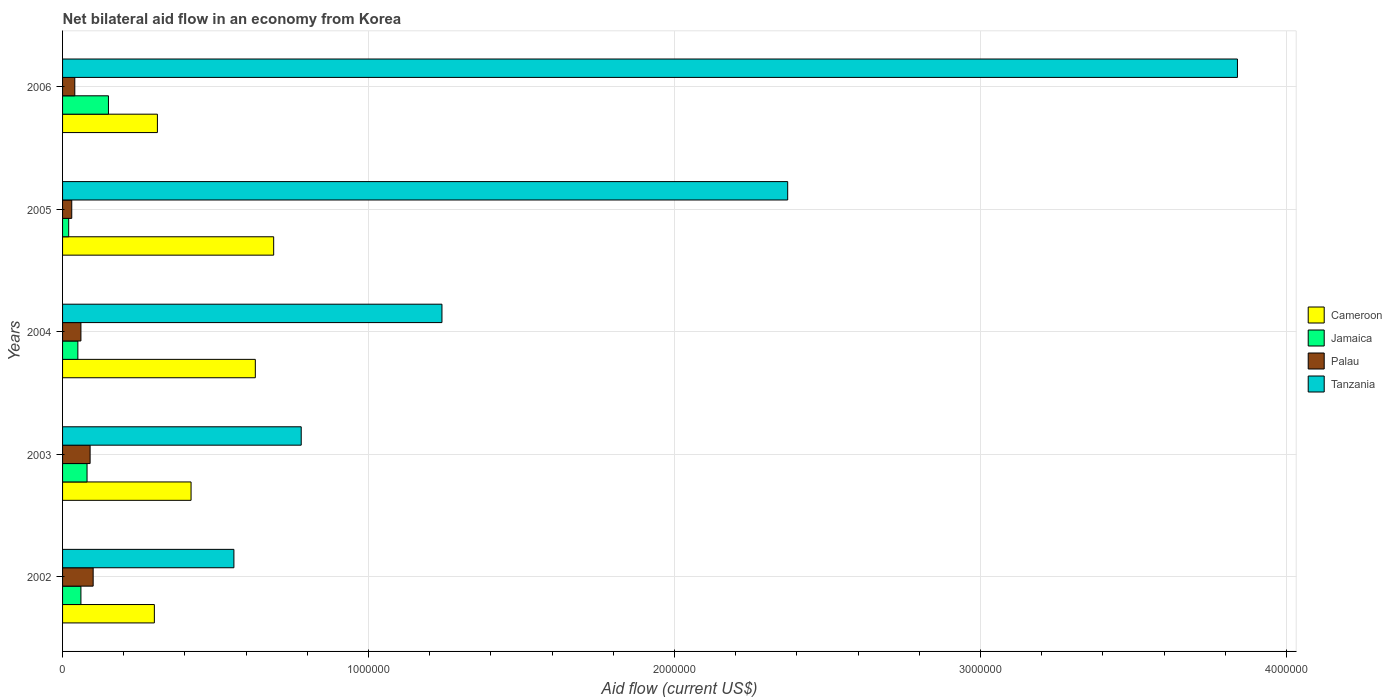Are the number of bars per tick equal to the number of legend labels?
Your answer should be compact. Yes. How many bars are there on the 4th tick from the top?
Your response must be concise. 4. How many bars are there on the 1st tick from the bottom?
Give a very brief answer. 4. What is the label of the 4th group of bars from the top?
Your answer should be compact. 2003. In how many cases, is the number of bars for a given year not equal to the number of legend labels?
Give a very brief answer. 0. Across all years, what is the maximum net bilateral aid flow in Jamaica?
Offer a very short reply. 1.50e+05. What is the total net bilateral aid flow in Cameroon in the graph?
Your answer should be compact. 2.35e+06. What is the difference between the net bilateral aid flow in Cameroon in 2006 and the net bilateral aid flow in Tanzania in 2005?
Keep it short and to the point. -2.06e+06. What is the average net bilateral aid flow in Palau per year?
Your answer should be very brief. 6.40e+04. In the year 2006, what is the difference between the net bilateral aid flow in Tanzania and net bilateral aid flow in Cameroon?
Offer a very short reply. 3.53e+06. What is the ratio of the net bilateral aid flow in Cameroon in 2004 to that in 2005?
Ensure brevity in your answer.  0.91. Is the net bilateral aid flow in Jamaica in 2002 less than that in 2003?
Your answer should be very brief. Yes. Is the difference between the net bilateral aid flow in Tanzania in 2002 and 2003 greater than the difference between the net bilateral aid flow in Cameroon in 2002 and 2003?
Your response must be concise. No. What is the difference between the highest and the lowest net bilateral aid flow in Tanzania?
Your response must be concise. 3.28e+06. In how many years, is the net bilateral aid flow in Cameroon greater than the average net bilateral aid flow in Cameroon taken over all years?
Offer a very short reply. 2. Is the sum of the net bilateral aid flow in Cameroon in 2002 and 2004 greater than the maximum net bilateral aid flow in Jamaica across all years?
Your answer should be very brief. Yes. Is it the case that in every year, the sum of the net bilateral aid flow in Jamaica and net bilateral aid flow in Tanzania is greater than the sum of net bilateral aid flow in Palau and net bilateral aid flow in Cameroon?
Your answer should be very brief. No. What does the 3rd bar from the top in 2006 represents?
Offer a very short reply. Jamaica. What does the 3rd bar from the bottom in 2003 represents?
Give a very brief answer. Palau. How many years are there in the graph?
Your response must be concise. 5. Where does the legend appear in the graph?
Offer a very short reply. Center right. How many legend labels are there?
Make the answer very short. 4. How are the legend labels stacked?
Your answer should be very brief. Vertical. What is the title of the graph?
Provide a short and direct response. Net bilateral aid flow in an economy from Korea. Does "Guyana" appear as one of the legend labels in the graph?
Offer a very short reply. No. What is the label or title of the X-axis?
Provide a succinct answer. Aid flow (current US$). What is the Aid flow (current US$) of Cameroon in 2002?
Offer a terse response. 3.00e+05. What is the Aid flow (current US$) in Tanzania in 2002?
Your answer should be compact. 5.60e+05. What is the Aid flow (current US$) of Tanzania in 2003?
Provide a short and direct response. 7.80e+05. What is the Aid flow (current US$) of Cameroon in 2004?
Your response must be concise. 6.30e+05. What is the Aid flow (current US$) of Tanzania in 2004?
Offer a very short reply. 1.24e+06. What is the Aid flow (current US$) of Cameroon in 2005?
Provide a succinct answer. 6.90e+05. What is the Aid flow (current US$) in Jamaica in 2005?
Give a very brief answer. 2.00e+04. What is the Aid flow (current US$) of Palau in 2005?
Provide a short and direct response. 3.00e+04. What is the Aid flow (current US$) of Tanzania in 2005?
Provide a short and direct response. 2.37e+06. What is the Aid flow (current US$) of Cameroon in 2006?
Offer a very short reply. 3.10e+05. What is the Aid flow (current US$) in Tanzania in 2006?
Your answer should be very brief. 3.84e+06. Across all years, what is the maximum Aid flow (current US$) in Cameroon?
Give a very brief answer. 6.90e+05. Across all years, what is the maximum Aid flow (current US$) of Jamaica?
Your response must be concise. 1.50e+05. Across all years, what is the maximum Aid flow (current US$) in Palau?
Offer a very short reply. 1.00e+05. Across all years, what is the maximum Aid flow (current US$) in Tanzania?
Your response must be concise. 3.84e+06. Across all years, what is the minimum Aid flow (current US$) of Cameroon?
Keep it short and to the point. 3.00e+05. Across all years, what is the minimum Aid flow (current US$) of Jamaica?
Offer a very short reply. 2.00e+04. Across all years, what is the minimum Aid flow (current US$) in Palau?
Offer a very short reply. 3.00e+04. Across all years, what is the minimum Aid flow (current US$) in Tanzania?
Your answer should be compact. 5.60e+05. What is the total Aid flow (current US$) of Cameroon in the graph?
Make the answer very short. 2.35e+06. What is the total Aid flow (current US$) of Palau in the graph?
Offer a terse response. 3.20e+05. What is the total Aid flow (current US$) of Tanzania in the graph?
Your response must be concise. 8.79e+06. What is the difference between the Aid flow (current US$) of Cameroon in 2002 and that in 2003?
Your answer should be very brief. -1.20e+05. What is the difference between the Aid flow (current US$) of Palau in 2002 and that in 2003?
Your answer should be very brief. 10000. What is the difference between the Aid flow (current US$) of Tanzania in 2002 and that in 2003?
Your response must be concise. -2.20e+05. What is the difference between the Aid flow (current US$) in Cameroon in 2002 and that in 2004?
Keep it short and to the point. -3.30e+05. What is the difference between the Aid flow (current US$) in Palau in 2002 and that in 2004?
Provide a short and direct response. 4.00e+04. What is the difference between the Aid flow (current US$) of Tanzania in 2002 and that in 2004?
Provide a succinct answer. -6.80e+05. What is the difference between the Aid flow (current US$) in Cameroon in 2002 and that in 2005?
Your answer should be compact. -3.90e+05. What is the difference between the Aid flow (current US$) of Tanzania in 2002 and that in 2005?
Ensure brevity in your answer.  -1.81e+06. What is the difference between the Aid flow (current US$) in Palau in 2002 and that in 2006?
Your answer should be compact. 6.00e+04. What is the difference between the Aid flow (current US$) in Tanzania in 2002 and that in 2006?
Provide a succinct answer. -3.28e+06. What is the difference between the Aid flow (current US$) in Palau in 2003 and that in 2004?
Your response must be concise. 3.00e+04. What is the difference between the Aid flow (current US$) in Tanzania in 2003 and that in 2004?
Ensure brevity in your answer.  -4.60e+05. What is the difference between the Aid flow (current US$) of Cameroon in 2003 and that in 2005?
Give a very brief answer. -2.70e+05. What is the difference between the Aid flow (current US$) of Jamaica in 2003 and that in 2005?
Provide a succinct answer. 6.00e+04. What is the difference between the Aid flow (current US$) in Tanzania in 2003 and that in 2005?
Offer a very short reply. -1.59e+06. What is the difference between the Aid flow (current US$) in Palau in 2003 and that in 2006?
Make the answer very short. 5.00e+04. What is the difference between the Aid flow (current US$) of Tanzania in 2003 and that in 2006?
Keep it short and to the point. -3.06e+06. What is the difference between the Aid flow (current US$) in Palau in 2004 and that in 2005?
Ensure brevity in your answer.  3.00e+04. What is the difference between the Aid flow (current US$) in Tanzania in 2004 and that in 2005?
Provide a succinct answer. -1.13e+06. What is the difference between the Aid flow (current US$) in Cameroon in 2004 and that in 2006?
Your answer should be compact. 3.20e+05. What is the difference between the Aid flow (current US$) in Palau in 2004 and that in 2006?
Provide a short and direct response. 2.00e+04. What is the difference between the Aid flow (current US$) of Tanzania in 2004 and that in 2006?
Keep it short and to the point. -2.60e+06. What is the difference between the Aid flow (current US$) of Cameroon in 2005 and that in 2006?
Keep it short and to the point. 3.80e+05. What is the difference between the Aid flow (current US$) of Jamaica in 2005 and that in 2006?
Your answer should be compact. -1.30e+05. What is the difference between the Aid flow (current US$) of Tanzania in 2005 and that in 2006?
Your response must be concise. -1.47e+06. What is the difference between the Aid flow (current US$) in Cameroon in 2002 and the Aid flow (current US$) in Tanzania in 2003?
Keep it short and to the point. -4.80e+05. What is the difference between the Aid flow (current US$) of Jamaica in 2002 and the Aid flow (current US$) of Tanzania in 2003?
Your answer should be compact. -7.20e+05. What is the difference between the Aid flow (current US$) of Palau in 2002 and the Aid flow (current US$) of Tanzania in 2003?
Make the answer very short. -6.80e+05. What is the difference between the Aid flow (current US$) in Cameroon in 2002 and the Aid flow (current US$) in Tanzania in 2004?
Offer a very short reply. -9.40e+05. What is the difference between the Aid flow (current US$) of Jamaica in 2002 and the Aid flow (current US$) of Palau in 2004?
Offer a terse response. 0. What is the difference between the Aid flow (current US$) in Jamaica in 2002 and the Aid flow (current US$) in Tanzania in 2004?
Provide a short and direct response. -1.18e+06. What is the difference between the Aid flow (current US$) of Palau in 2002 and the Aid flow (current US$) of Tanzania in 2004?
Give a very brief answer. -1.14e+06. What is the difference between the Aid flow (current US$) in Cameroon in 2002 and the Aid flow (current US$) in Jamaica in 2005?
Ensure brevity in your answer.  2.80e+05. What is the difference between the Aid flow (current US$) in Cameroon in 2002 and the Aid flow (current US$) in Tanzania in 2005?
Keep it short and to the point. -2.07e+06. What is the difference between the Aid flow (current US$) in Jamaica in 2002 and the Aid flow (current US$) in Tanzania in 2005?
Your response must be concise. -2.31e+06. What is the difference between the Aid flow (current US$) in Palau in 2002 and the Aid flow (current US$) in Tanzania in 2005?
Keep it short and to the point. -2.27e+06. What is the difference between the Aid flow (current US$) in Cameroon in 2002 and the Aid flow (current US$) in Palau in 2006?
Your answer should be very brief. 2.60e+05. What is the difference between the Aid flow (current US$) of Cameroon in 2002 and the Aid flow (current US$) of Tanzania in 2006?
Your response must be concise. -3.54e+06. What is the difference between the Aid flow (current US$) of Jamaica in 2002 and the Aid flow (current US$) of Palau in 2006?
Offer a terse response. 2.00e+04. What is the difference between the Aid flow (current US$) of Jamaica in 2002 and the Aid flow (current US$) of Tanzania in 2006?
Ensure brevity in your answer.  -3.78e+06. What is the difference between the Aid flow (current US$) of Palau in 2002 and the Aid flow (current US$) of Tanzania in 2006?
Your response must be concise. -3.74e+06. What is the difference between the Aid flow (current US$) in Cameroon in 2003 and the Aid flow (current US$) in Jamaica in 2004?
Provide a succinct answer. 3.70e+05. What is the difference between the Aid flow (current US$) of Cameroon in 2003 and the Aid flow (current US$) of Palau in 2004?
Your answer should be very brief. 3.60e+05. What is the difference between the Aid flow (current US$) in Cameroon in 2003 and the Aid flow (current US$) in Tanzania in 2004?
Offer a very short reply. -8.20e+05. What is the difference between the Aid flow (current US$) of Jamaica in 2003 and the Aid flow (current US$) of Tanzania in 2004?
Ensure brevity in your answer.  -1.16e+06. What is the difference between the Aid flow (current US$) in Palau in 2003 and the Aid flow (current US$) in Tanzania in 2004?
Your answer should be very brief. -1.15e+06. What is the difference between the Aid flow (current US$) in Cameroon in 2003 and the Aid flow (current US$) in Palau in 2005?
Offer a very short reply. 3.90e+05. What is the difference between the Aid flow (current US$) in Cameroon in 2003 and the Aid flow (current US$) in Tanzania in 2005?
Keep it short and to the point. -1.95e+06. What is the difference between the Aid flow (current US$) in Jamaica in 2003 and the Aid flow (current US$) in Tanzania in 2005?
Offer a very short reply. -2.29e+06. What is the difference between the Aid flow (current US$) in Palau in 2003 and the Aid flow (current US$) in Tanzania in 2005?
Make the answer very short. -2.28e+06. What is the difference between the Aid flow (current US$) of Cameroon in 2003 and the Aid flow (current US$) of Tanzania in 2006?
Your answer should be very brief. -3.42e+06. What is the difference between the Aid flow (current US$) of Jamaica in 2003 and the Aid flow (current US$) of Tanzania in 2006?
Your response must be concise. -3.76e+06. What is the difference between the Aid flow (current US$) in Palau in 2003 and the Aid flow (current US$) in Tanzania in 2006?
Provide a short and direct response. -3.75e+06. What is the difference between the Aid flow (current US$) in Cameroon in 2004 and the Aid flow (current US$) in Jamaica in 2005?
Your response must be concise. 6.10e+05. What is the difference between the Aid flow (current US$) in Cameroon in 2004 and the Aid flow (current US$) in Tanzania in 2005?
Offer a terse response. -1.74e+06. What is the difference between the Aid flow (current US$) of Jamaica in 2004 and the Aid flow (current US$) of Palau in 2005?
Give a very brief answer. 2.00e+04. What is the difference between the Aid flow (current US$) in Jamaica in 2004 and the Aid flow (current US$) in Tanzania in 2005?
Your answer should be very brief. -2.32e+06. What is the difference between the Aid flow (current US$) in Palau in 2004 and the Aid flow (current US$) in Tanzania in 2005?
Provide a succinct answer. -2.31e+06. What is the difference between the Aid flow (current US$) of Cameroon in 2004 and the Aid flow (current US$) of Jamaica in 2006?
Your response must be concise. 4.80e+05. What is the difference between the Aid flow (current US$) of Cameroon in 2004 and the Aid flow (current US$) of Palau in 2006?
Make the answer very short. 5.90e+05. What is the difference between the Aid flow (current US$) in Cameroon in 2004 and the Aid flow (current US$) in Tanzania in 2006?
Ensure brevity in your answer.  -3.21e+06. What is the difference between the Aid flow (current US$) in Jamaica in 2004 and the Aid flow (current US$) in Palau in 2006?
Keep it short and to the point. 10000. What is the difference between the Aid flow (current US$) of Jamaica in 2004 and the Aid flow (current US$) of Tanzania in 2006?
Ensure brevity in your answer.  -3.79e+06. What is the difference between the Aid flow (current US$) in Palau in 2004 and the Aid flow (current US$) in Tanzania in 2006?
Offer a very short reply. -3.78e+06. What is the difference between the Aid flow (current US$) in Cameroon in 2005 and the Aid flow (current US$) in Jamaica in 2006?
Provide a succinct answer. 5.40e+05. What is the difference between the Aid flow (current US$) in Cameroon in 2005 and the Aid flow (current US$) in Palau in 2006?
Offer a terse response. 6.50e+05. What is the difference between the Aid flow (current US$) in Cameroon in 2005 and the Aid flow (current US$) in Tanzania in 2006?
Your answer should be very brief. -3.15e+06. What is the difference between the Aid flow (current US$) of Jamaica in 2005 and the Aid flow (current US$) of Tanzania in 2006?
Make the answer very short. -3.82e+06. What is the difference between the Aid flow (current US$) in Palau in 2005 and the Aid flow (current US$) in Tanzania in 2006?
Ensure brevity in your answer.  -3.81e+06. What is the average Aid flow (current US$) of Cameroon per year?
Ensure brevity in your answer.  4.70e+05. What is the average Aid flow (current US$) of Jamaica per year?
Make the answer very short. 7.20e+04. What is the average Aid flow (current US$) of Palau per year?
Give a very brief answer. 6.40e+04. What is the average Aid flow (current US$) of Tanzania per year?
Offer a terse response. 1.76e+06. In the year 2002, what is the difference between the Aid flow (current US$) in Cameroon and Aid flow (current US$) in Jamaica?
Provide a succinct answer. 2.40e+05. In the year 2002, what is the difference between the Aid flow (current US$) in Cameroon and Aid flow (current US$) in Palau?
Your answer should be compact. 2.00e+05. In the year 2002, what is the difference between the Aid flow (current US$) in Cameroon and Aid flow (current US$) in Tanzania?
Make the answer very short. -2.60e+05. In the year 2002, what is the difference between the Aid flow (current US$) in Jamaica and Aid flow (current US$) in Tanzania?
Your answer should be compact. -5.00e+05. In the year 2002, what is the difference between the Aid flow (current US$) in Palau and Aid flow (current US$) in Tanzania?
Provide a succinct answer. -4.60e+05. In the year 2003, what is the difference between the Aid flow (current US$) in Cameroon and Aid flow (current US$) in Jamaica?
Your answer should be compact. 3.40e+05. In the year 2003, what is the difference between the Aid flow (current US$) of Cameroon and Aid flow (current US$) of Palau?
Make the answer very short. 3.30e+05. In the year 2003, what is the difference between the Aid flow (current US$) of Cameroon and Aid flow (current US$) of Tanzania?
Make the answer very short. -3.60e+05. In the year 2003, what is the difference between the Aid flow (current US$) in Jamaica and Aid flow (current US$) in Tanzania?
Your response must be concise. -7.00e+05. In the year 2003, what is the difference between the Aid flow (current US$) in Palau and Aid flow (current US$) in Tanzania?
Provide a short and direct response. -6.90e+05. In the year 2004, what is the difference between the Aid flow (current US$) in Cameroon and Aid flow (current US$) in Jamaica?
Provide a short and direct response. 5.80e+05. In the year 2004, what is the difference between the Aid flow (current US$) of Cameroon and Aid flow (current US$) of Palau?
Ensure brevity in your answer.  5.70e+05. In the year 2004, what is the difference between the Aid flow (current US$) of Cameroon and Aid flow (current US$) of Tanzania?
Provide a succinct answer. -6.10e+05. In the year 2004, what is the difference between the Aid flow (current US$) in Jamaica and Aid flow (current US$) in Tanzania?
Provide a succinct answer. -1.19e+06. In the year 2004, what is the difference between the Aid flow (current US$) of Palau and Aid flow (current US$) of Tanzania?
Your answer should be very brief. -1.18e+06. In the year 2005, what is the difference between the Aid flow (current US$) of Cameroon and Aid flow (current US$) of Jamaica?
Your answer should be compact. 6.70e+05. In the year 2005, what is the difference between the Aid flow (current US$) of Cameroon and Aid flow (current US$) of Palau?
Provide a short and direct response. 6.60e+05. In the year 2005, what is the difference between the Aid flow (current US$) in Cameroon and Aid flow (current US$) in Tanzania?
Give a very brief answer. -1.68e+06. In the year 2005, what is the difference between the Aid flow (current US$) of Jamaica and Aid flow (current US$) of Palau?
Give a very brief answer. -10000. In the year 2005, what is the difference between the Aid flow (current US$) of Jamaica and Aid flow (current US$) of Tanzania?
Make the answer very short. -2.35e+06. In the year 2005, what is the difference between the Aid flow (current US$) of Palau and Aid flow (current US$) of Tanzania?
Provide a short and direct response. -2.34e+06. In the year 2006, what is the difference between the Aid flow (current US$) of Cameroon and Aid flow (current US$) of Jamaica?
Keep it short and to the point. 1.60e+05. In the year 2006, what is the difference between the Aid flow (current US$) in Cameroon and Aid flow (current US$) in Tanzania?
Ensure brevity in your answer.  -3.53e+06. In the year 2006, what is the difference between the Aid flow (current US$) of Jamaica and Aid flow (current US$) of Tanzania?
Keep it short and to the point. -3.69e+06. In the year 2006, what is the difference between the Aid flow (current US$) in Palau and Aid flow (current US$) in Tanzania?
Provide a succinct answer. -3.80e+06. What is the ratio of the Aid flow (current US$) of Cameroon in 2002 to that in 2003?
Keep it short and to the point. 0.71. What is the ratio of the Aid flow (current US$) of Jamaica in 2002 to that in 2003?
Give a very brief answer. 0.75. What is the ratio of the Aid flow (current US$) of Palau in 2002 to that in 2003?
Your response must be concise. 1.11. What is the ratio of the Aid flow (current US$) of Tanzania in 2002 to that in 2003?
Offer a very short reply. 0.72. What is the ratio of the Aid flow (current US$) in Cameroon in 2002 to that in 2004?
Your answer should be very brief. 0.48. What is the ratio of the Aid flow (current US$) of Jamaica in 2002 to that in 2004?
Make the answer very short. 1.2. What is the ratio of the Aid flow (current US$) of Palau in 2002 to that in 2004?
Your answer should be very brief. 1.67. What is the ratio of the Aid flow (current US$) in Tanzania in 2002 to that in 2004?
Offer a terse response. 0.45. What is the ratio of the Aid flow (current US$) of Cameroon in 2002 to that in 2005?
Ensure brevity in your answer.  0.43. What is the ratio of the Aid flow (current US$) of Tanzania in 2002 to that in 2005?
Your response must be concise. 0.24. What is the ratio of the Aid flow (current US$) in Jamaica in 2002 to that in 2006?
Provide a succinct answer. 0.4. What is the ratio of the Aid flow (current US$) of Tanzania in 2002 to that in 2006?
Give a very brief answer. 0.15. What is the ratio of the Aid flow (current US$) in Cameroon in 2003 to that in 2004?
Your answer should be compact. 0.67. What is the ratio of the Aid flow (current US$) of Jamaica in 2003 to that in 2004?
Give a very brief answer. 1.6. What is the ratio of the Aid flow (current US$) in Tanzania in 2003 to that in 2004?
Keep it short and to the point. 0.63. What is the ratio of the Aid flow (current US$) in Cameroon in 2003 to that in 2005?
Keep it short and to the point. 0.61. What is the ratio of the Aid flow (current US$) of Jamaica in 2003 to that in 2005?
Offer a very short reply. 4. What is the ratio of the Aid flow (current US$) of Palau in 2003 to that in 2005?
Give a very brief answer. 3. What is the ratio of the Aid flow (current US$) in Tanzania in 2003 to that in 2005?
Offer a very short reply. 0.33. What is the ratio of the Aid flow (current US$) of Cameroon in 2003 to that in 2006?
Your response must be concise. 1.35. What is the ratio of the Aid flow (current US$) in Jamaica in 2003 to that in 2006?
Offer a very short reply. 0.53. What is the ratio of the Aid flow (current US$) in Palau in 2003 to that in 2006?
Provide a short and direct response. 2.25. What is the ratio of the Aid flow (current US$) of Tanzania in 2003 to that in 2006?
Your answer should be very brief. 0.2. What is the ratio of the Aid flow (current US$) of Cameroon in 2004 to that in 2005?
Your answer should be compact. 0.91. What is the ratio of the Aid flow (current US$) in Jamaica in 2004 to that in 2005?
Give a very brief answer. 2.5. What is the ratio of the Aid flow (current US$) of Tanzania in 2004 to that in 2005?
Provide a short and direct response. 0.52. What is the ratio of the Aid flow (current US$) in Cameroon in 2004 to that in 2006?
Make the answer very short. 2.03. What is the ratio of the Aid flow (current US$) in Jamaica in 2004 to that in 2006?
Offer a very short reply. 0.33. What is the ratio of the Aid flow (current US$) of Palau in 2004 to that in 2006?
Your answer should be compact. 1.5. What is the ratio of the Aid flow (current US$) of Tanzania in 2004 to that in 2006?
Offer a terse response. 0.32. What is the ratio of the Aid flow (current US$) in Cameroon in 2005 to that in 2006?
Provide a succinct answer. 2.23. What is the ratio of the Aid flow (current US$) of Jamaica in 2005 to that in 2006?
Keep it short and to the point. 0.13. What is the ratio of the Aid flow (current US$) of Palau in 2005 to that in 2006?
Provide a short and direct response. 0.75. What is the ratio of the Aid flow (current US$) of Tanzania in 2005 to that in 2006?
Keep it short and to the point. 0.62. What is the difference between the highest and the second highest Aid flow (current US$) in Cameroon?
Make the answer very short. 6.00e+04. What is the difference between the highest and the second highest Aid flow (current US$) of Palau?
Give a very brief answer. 10000. What is the difference between the highest and the second highest Aid flow (current US$) in Tanzania?
Your answer should be compact. 1.47e+06. What is the difference between the highest and the lowest Aid flow (current US$) of Cameroon?
Provide a succinct answer. 3.90e+05. What is the difference between the highest and the lowest Aid flow (current US$) in Tanzania?
Offer a very short reply. 3.28e+06. 